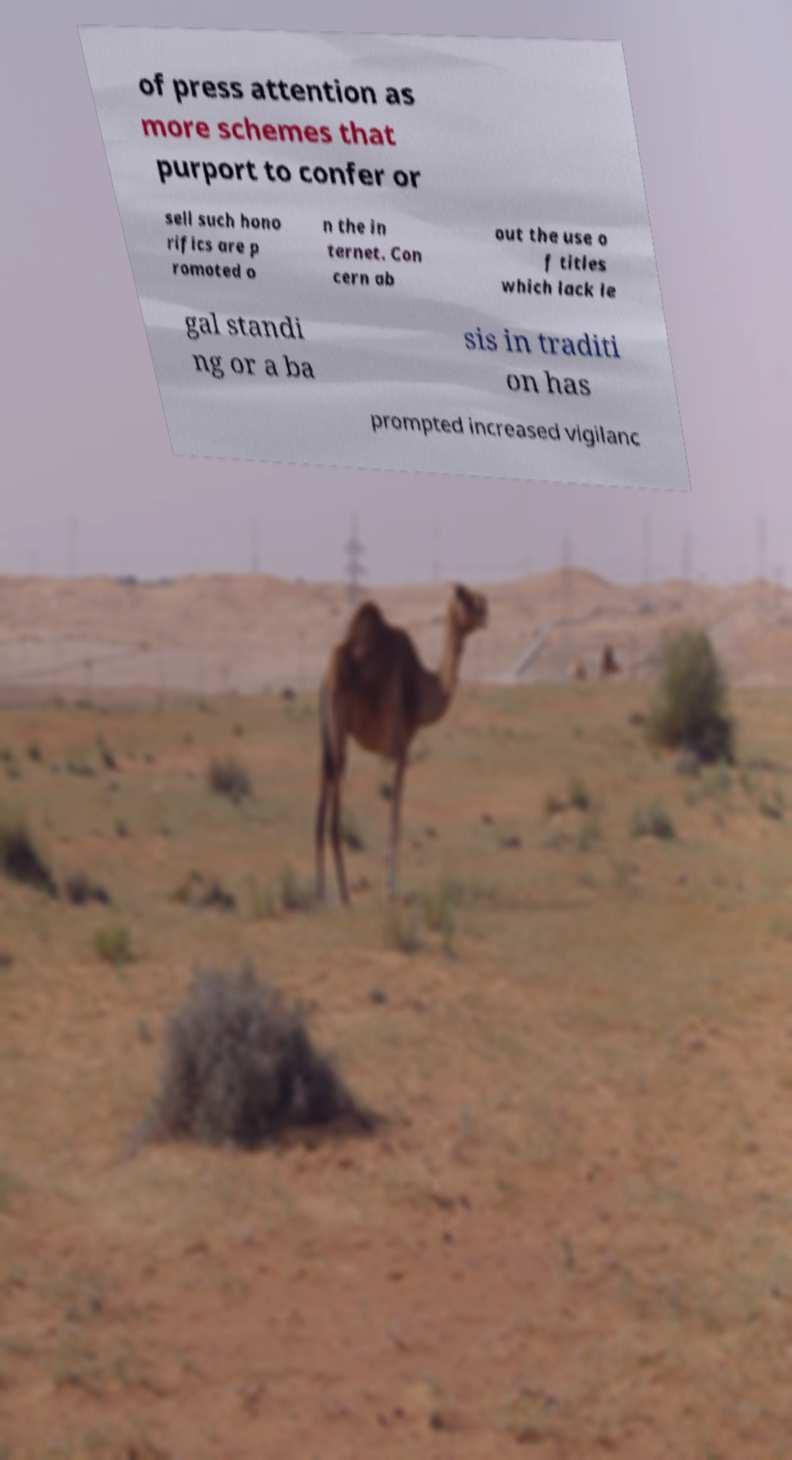There's text embedded in this image that I need extracted. Can you transcribe it verbatim? of press attention as more schemes that purport to confer or sell such hono rifics are p romoted o n the in ternet. Con cern ab out the use o f titles which lack le gal standi ng or a ba sis in traditi on has prompted increased vigilanc 